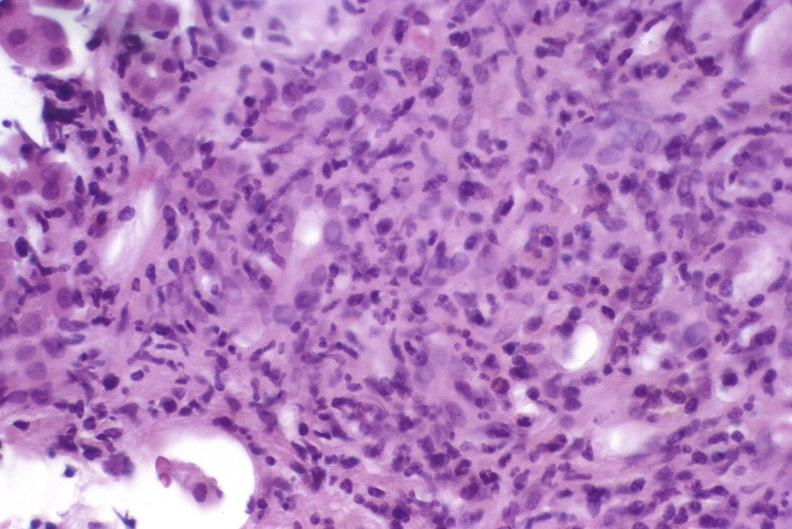does corpus luteum show autoimmune hepatitis?
Answer the question using a single word or phrase. No 